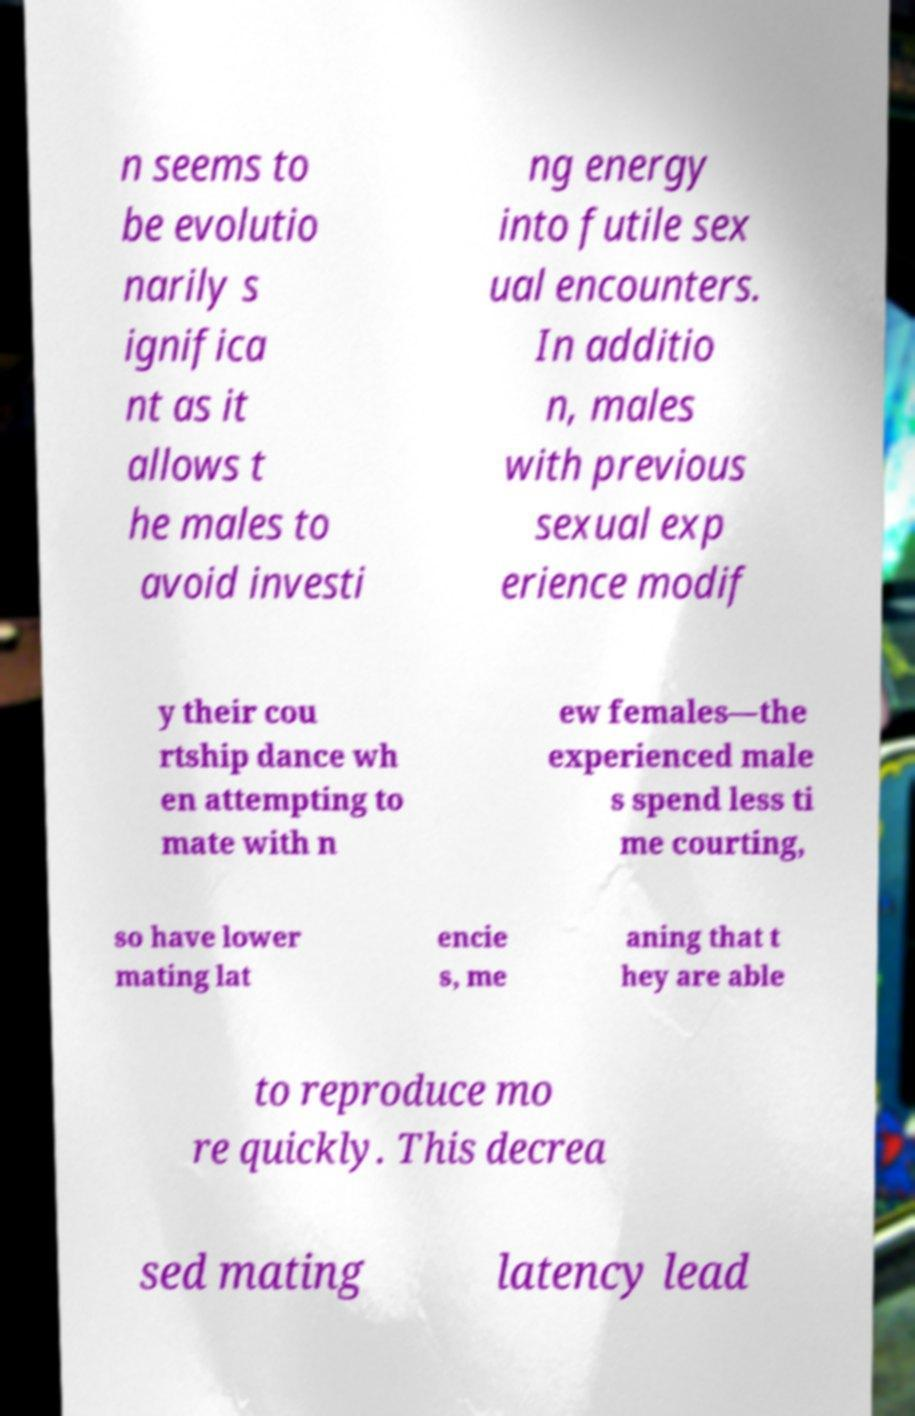There's text embedded in this image that I need extracted. Can you transcribe it verbatim? n seems to be evolutio narily s ignifica nt as it allows t he males to avoid investi ng energy into futile sex ual encounters. In additio n, males with previous sexual exp erience modif y their cou rtship dance wh en attempting to mate with n ew females—the experienced male s spend less ti me courting, so have lower mating lat encie s, me aning that t hey are able to reproduce mo re quickly. This decrea sed mating latency lead 